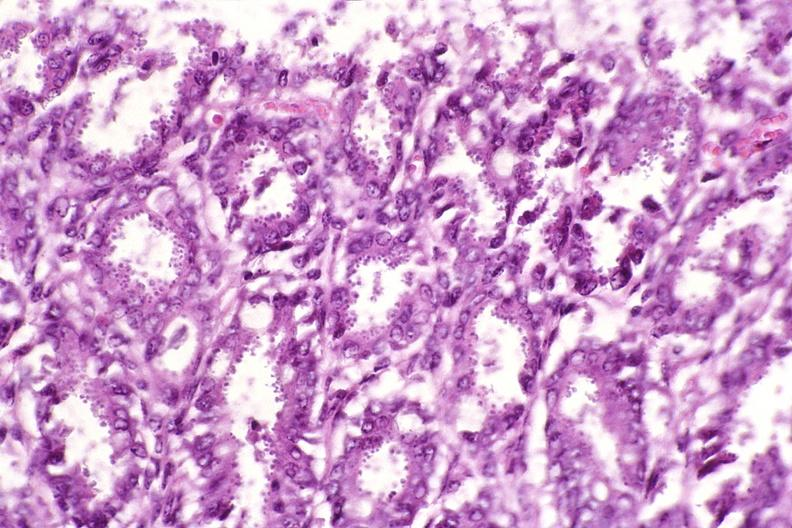what is present?
Answer the question using a single word or phrase. Gastrointestinal 